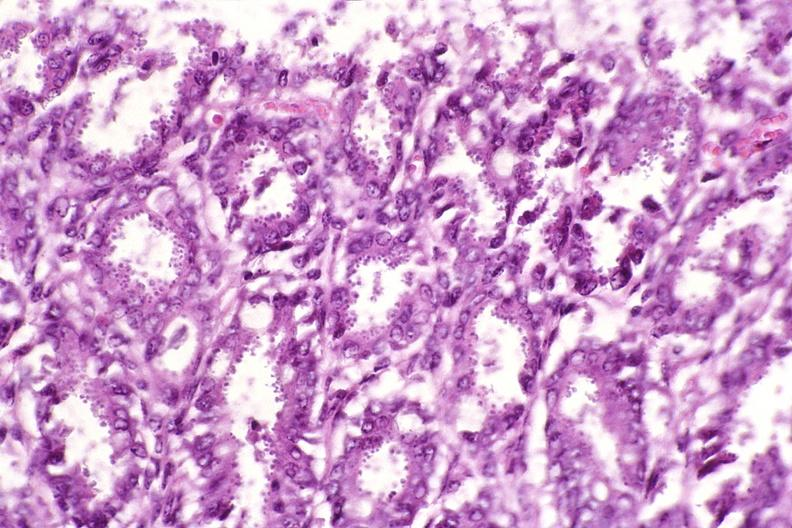what is present?
Answer the question using a single word or phrase. Gastrointestinal 